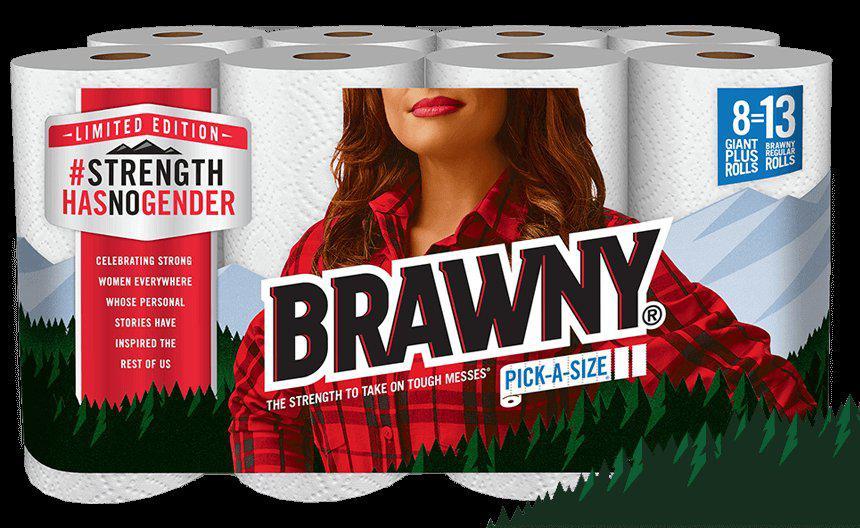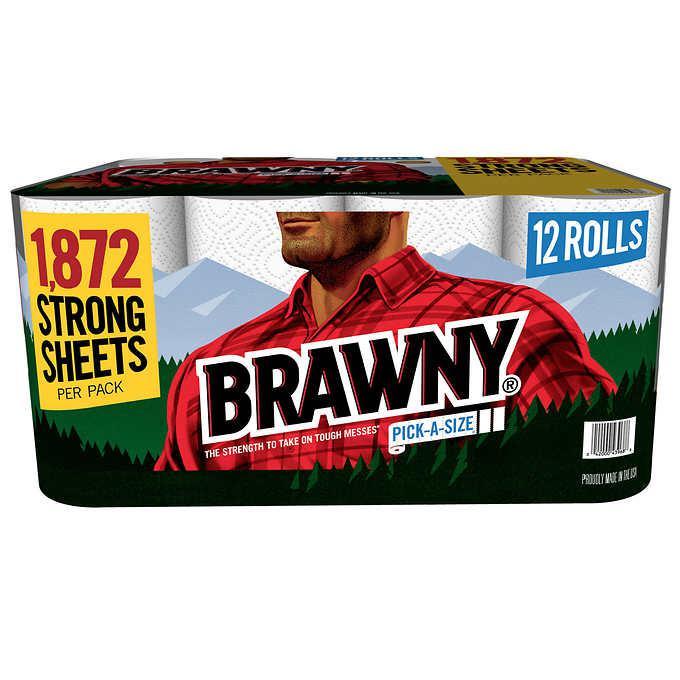The first image is the image on the left, the second image is the image on the right. Considering the images on both sides, is "There are at least six rolls of paper towels in the package on the left." valid? Answer yes or no. Yes. 